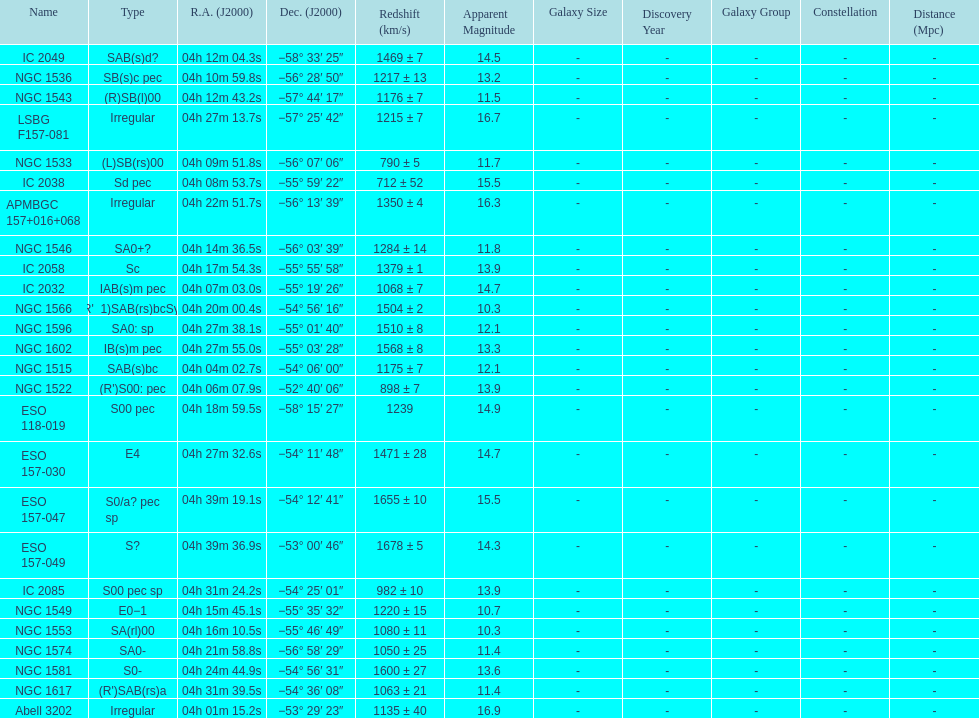What number of "irregular" types are there? 3. 